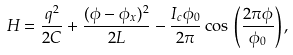<formula> <loc_0><loc_0><loc_500><loc_500>H = \frac { q ^ { 2 } } { 2 C } + \frac { ( \phi - \phi _ { x } ) ^ { 2 } } { 2 L } - \frac { I _ { c } \phi _ { 0 } } { 2 \pi } \cos \, \left ( \frac { 2 \pi \phi } { \phi _ { 0 } } \right ) ,</formula> 